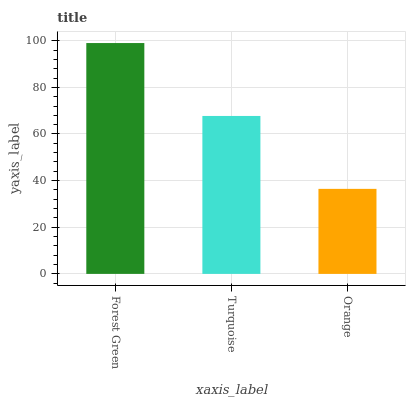Is Orange the minimum?
Answer yes or no. Yes. Is Forest Green the maximum?
Answer yes or no. Yes. Is Turquoise the minimum?
Answer yes or no. No. Is Turquoise the maximum?
Answer yes or no. No. Is Forest Green greater than Turquoise?
Answer yes or no. Yes. Is Turquoise less than Forest Green?
Answer yes or no. Yes. Is Turquoise greater than Forest Green?
Answer yes or no. No. Is Forest Green less than Turquoise?
Answer yes or no. No. Is Turquoise the high median?
Answer yes or no. Yes. Is Turquoise the low median?
Answer yes or no. Yes. Is Orange the high median?
Answer yes or no. No. Is Orange the low median?
Answer yes or no. No. 